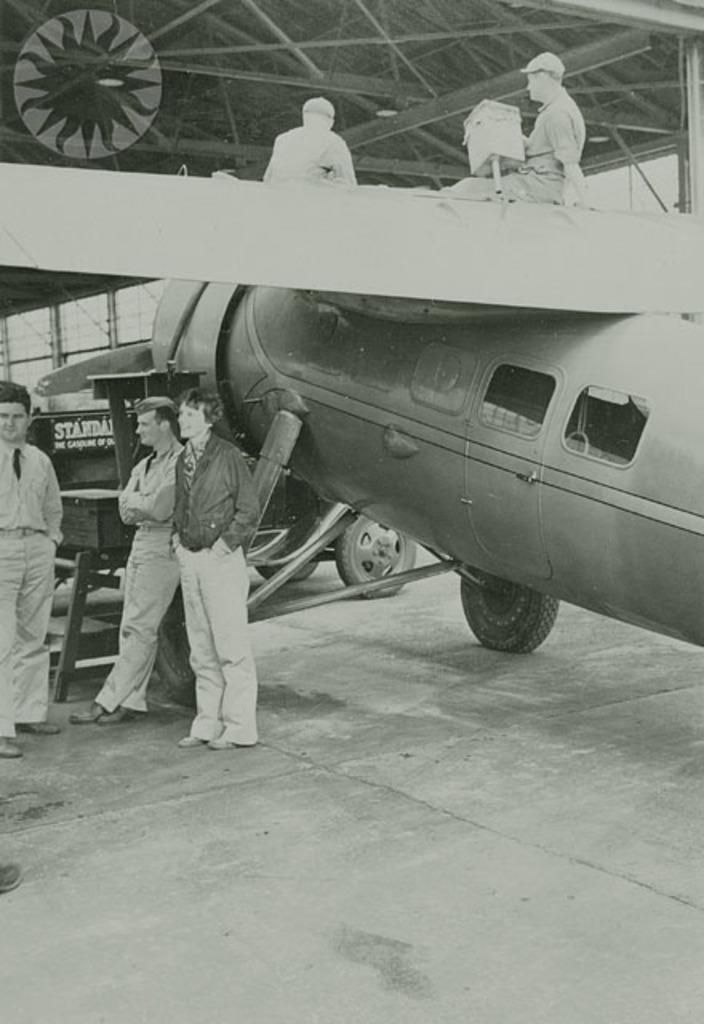How many people are in the image? There are many people in the image. What type of vehicle is present in the image? There is a jet plane in the image. What is at the bottom of the image? There is a road at the bottom of the image. What is the color scheme of the image? The image appears to be in black and white. Can you tell me who is having an argument with their grandfather in the image? There is no mention of an argument or a grandfather in the image; it features many people and a jet plane. 